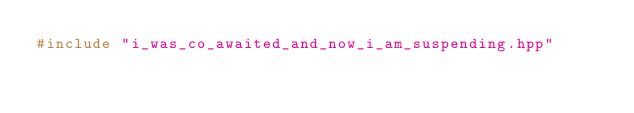Convert code to text. <code><loc_0><loc_0><loc_500><loc_500><_C++_>#include "i_was_co_awaited_and_now_i_am_suspending.hpp"</code> 